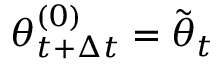Convert formula to latex. <formula><loc_0><loc_0><loc_500><loc_500>{ \theta } _ { t + \Delta t } ^ { ( 0 ) } = \tilde { \theta } _ { t }</formula> 